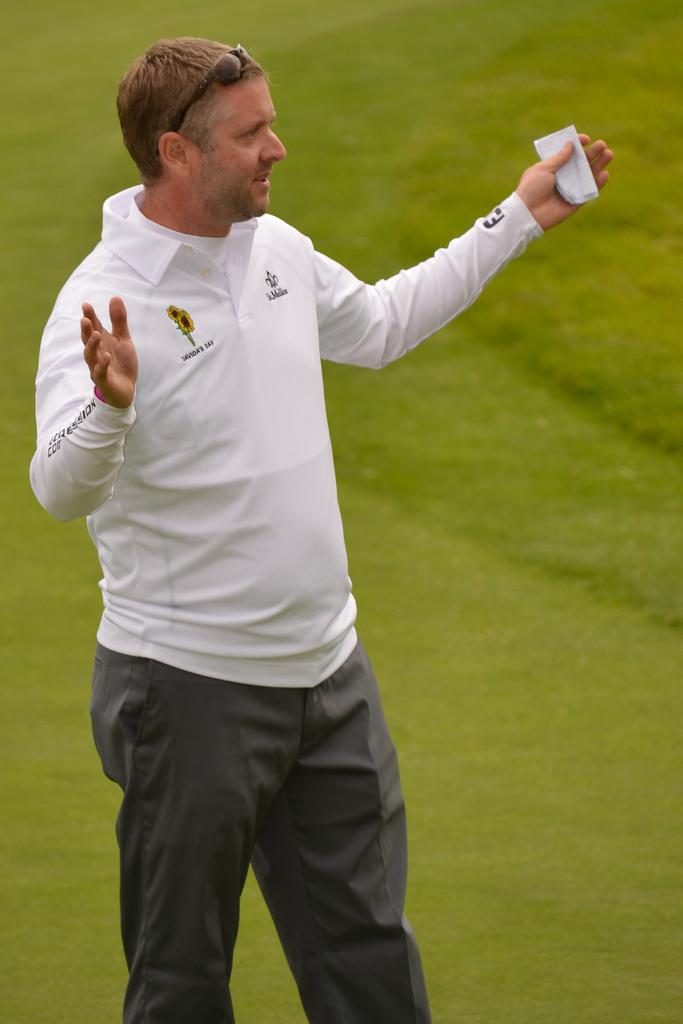What is the main subject of the image? There is a man standing in the image. What type of environment is visible in the background of the image? There is grass visible in the background of the image. What type of earthquake can be seen in the image? There is no earthquake present in the image. What type of porter is visible in the image? There is no porter present in the image. 